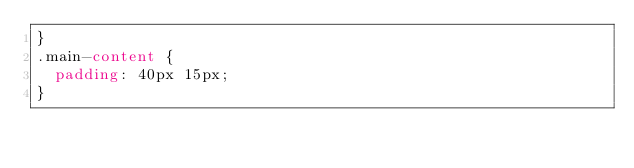<code> <loc_0><loc_0><loc_500><loc_500><_CSS_>}
.main-content {
  padding: 40px 15px;
}</code> 